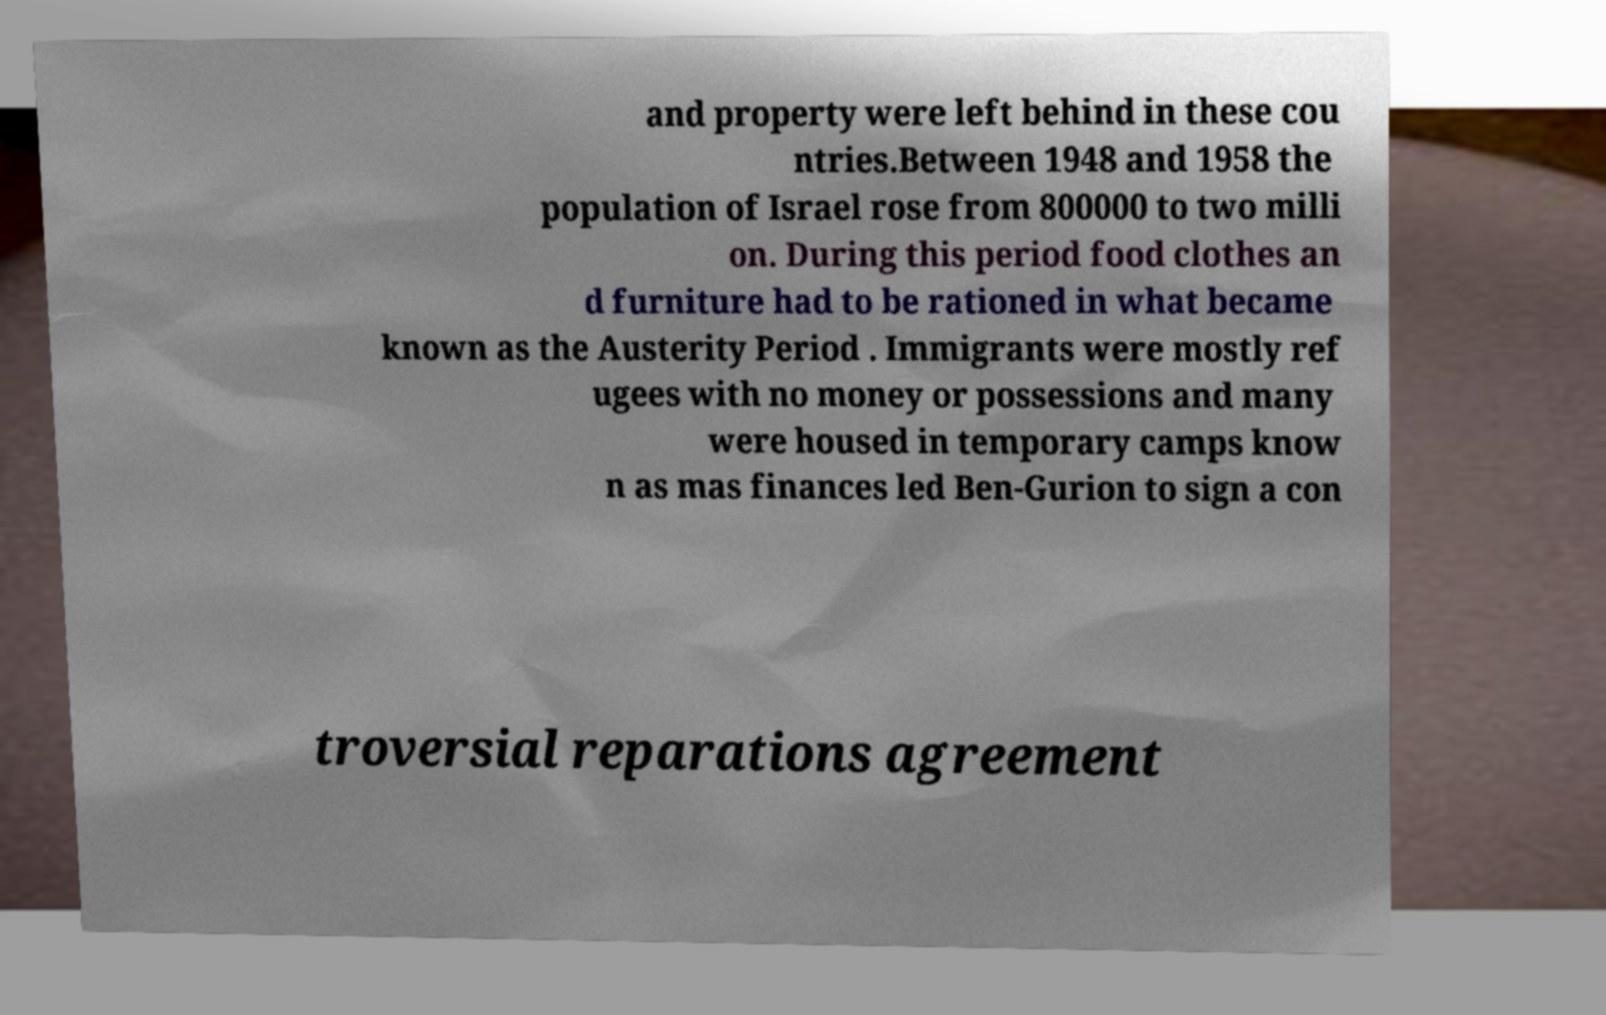I need the written content from this picture converted into text. Can you do that? and property were left behind in these cou ntries.Between 1948 and 1958 the population of Israel rose from 800000 to two milli on. During this period food clothes an d furniture had to be rationed in what became known as the Austerity Period . Immigrants were mostly ref ugees with no money or possessions and many were housed in temporary camps know n as mas finances led Ben-Gurion to sign a con troversial reparations agreement 